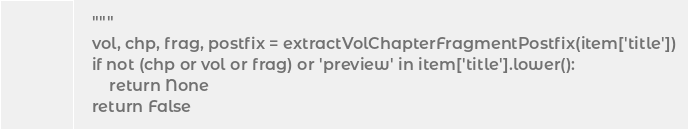Convert code to text. <code><loc_0><loc_0><loc_500><loc_500><_Python_>	"""
	vol, chp, frag, postfix = extractVolChapterFragmentPostfix(item['title'])
	if not (chp or vol or frag) or 'preview' in item['title'].lower():
		return None
	return False
</code> 